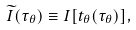<formula> <loc_0><loc_0><loc_500><loc_500>\widetilde { I } ( \tau _ { \theta } ) \equiv I [ t _ { \theta } ( \tau _ { \theta } ) ] ,</formula> 